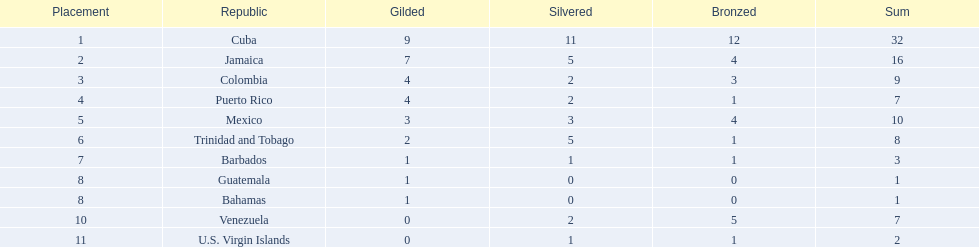Which 3 countries were awarded the most medals? Cuba, Jamaica, Colombia. Of these 3 countries which ones are islands? Cuba, Jamaica. Which one won the most silver medals? Cuba. 